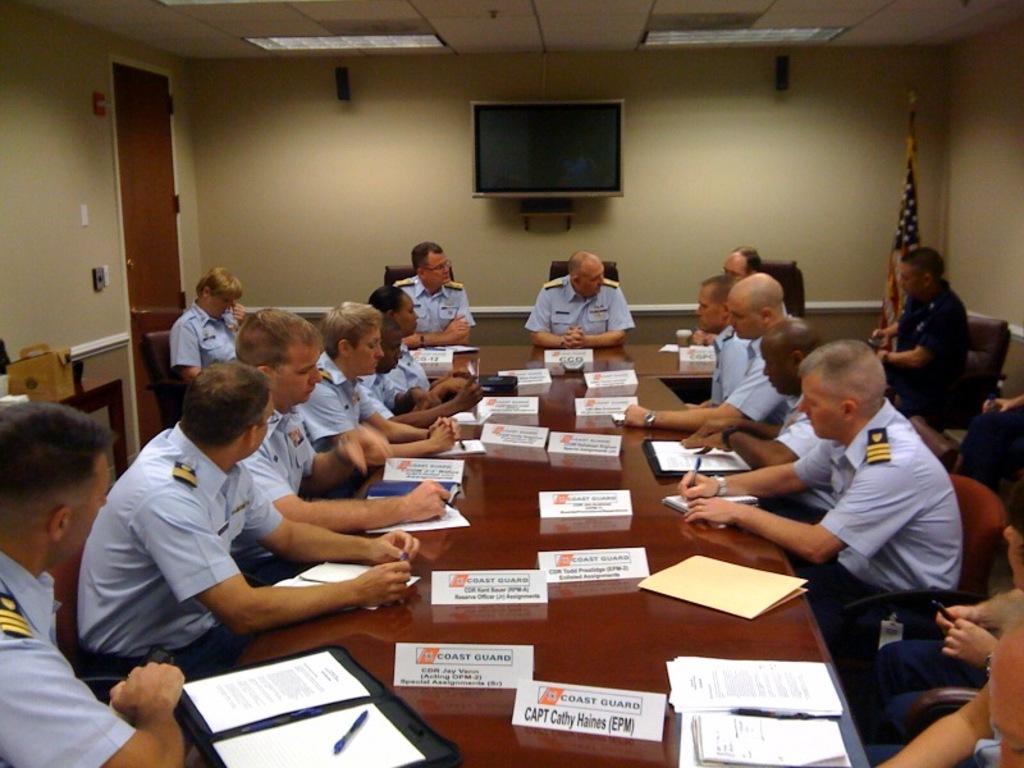Does this meeting look interesting?
Provide a short and direct response. Answering does not require reading text in the image. What is the captain's name?
Give a very brief answer. Cathy haines. 